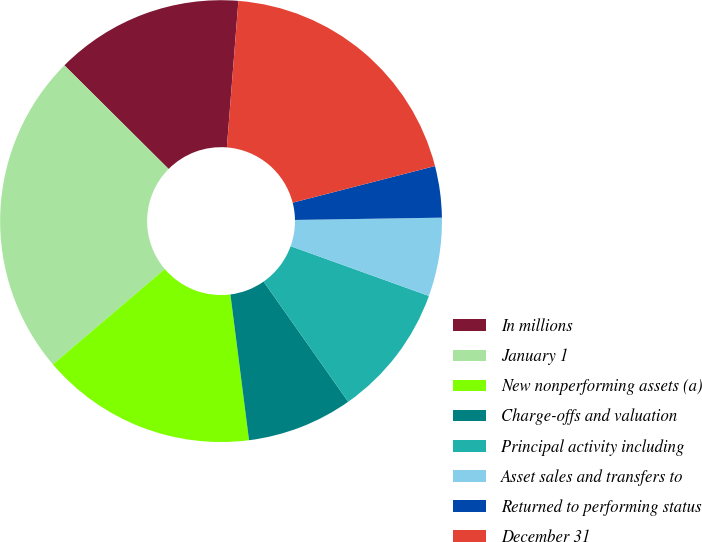Convert chart. <chart><loc_0><loc_0><loc_500><loc_500><pie_chart><fcel>In millions<fcel>January 1<fcel>New nonperforming assets (a)<fcel>Charge-offs and valuation<fcel>Principal activity including<fcel>Asset sales and transfers to<fcel>Returned to performing status<fcel>December 31<nl><fcel>13.8%<fcel>23.69%<fcel>15.79%<fcel>7.74%<fcel>9.74%<fcel>5.75%<fcel>3.76%<fcel>19.74%<nl></chart> 